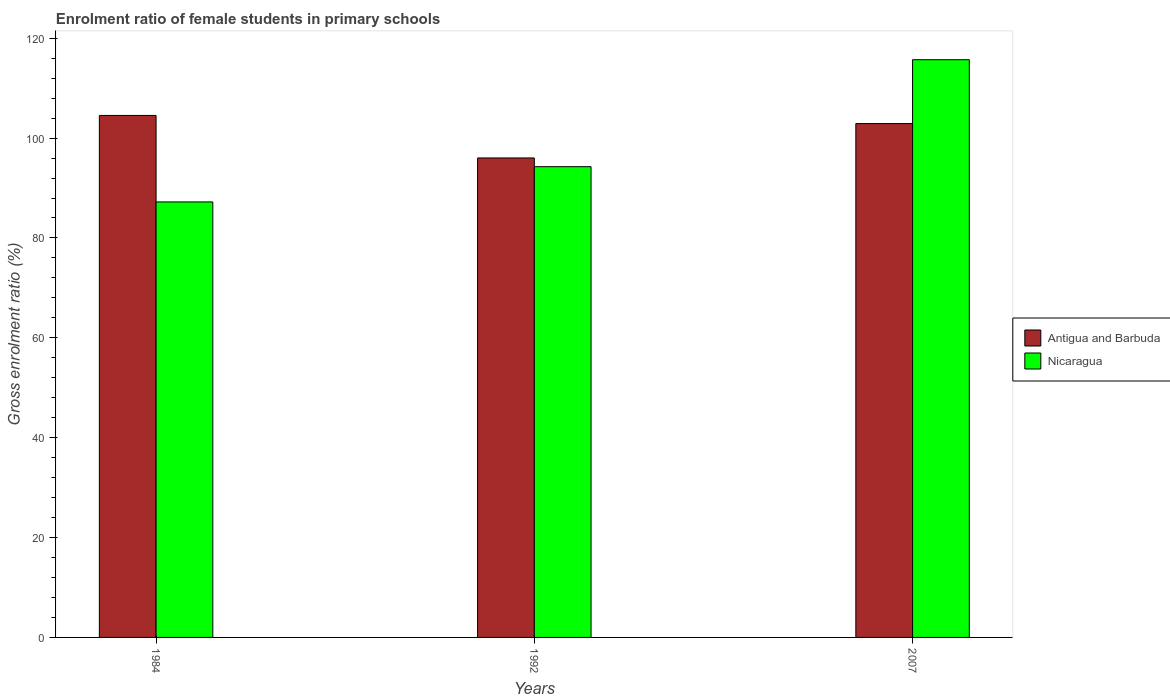How many groups of bars are there?
Provide a short and direct response. 3. Are the number of bars per tick equal to the number of legend labels?
Your response must be concise. Yes. Are the number of bars on each tick of the X-axis equal?
Provide a short and direct response. Yes. How many bars are there on the 2nd tick from the left?
Offer a terse response. 2. What is the label of the 1st group of bars from the left?
Provide a succinct answer. 1984. In how many cases, is the number of bars for a given year not equal to the number of legend labels?
Give a very brief answer. 0. What is the enrolment ratio of female students in primary schools in Antigua and Barbuda in 2007?
Provide a succinct answer. 102.91. Across all years, what is the maximum enrolment ratio of female students in primary schools in Nicaragua?
Make the answer very short. 115.7. Across all years, what is the minimum enrolment ratio of female students in primary schools in Antigua and Barbuda?
Offer a terse response. 96.03. In which year was the enrolment ratio of female students in primary schools in Nicaragua minimum?
Your answer should be very brief. 1984. What is the total enrolment ratio of female students in primary schools in Nicaragua in the graph?
Give a very brief answer. 297.19. What is the difference between the enrolment ratio of female students in primary schools in Antigua and Barbuda in 1984 and that in 1992?
Your answer should be compact. 8.51. What is the difference between the enrolment ratio of female students in primary schools in Nicaragua in 1992 and the enrolment ratio of female students in primary schools in Antigua and Barbuda in 1984?
Provide a succinct answer. -10.26. What is the average enrolment ratio of female students in primary schools in Antigua and Barbuda per year?
Keep it short and to the point. 101.16. In the year 2007, what is the difference between the enrolment ratio of female students in primary schools in Antigua and Barbuda and enrolment ratio of female students in primary schools in Nicaragua?
Ensure brevity in your answer.  -12.79. What is the ratio of the enrolment ratio of female students in primary schools in Antigua and Barbuda in 1984 to that in 2007?
Your answer should be compact. 1.02. What is the difference between the highest and the second highest enrolment ratio of female students in primary schools in Antigua and Barbuda?
Keep it short and to the point. 1.63. What is the difference between the highest and the lowest enrolment ratio of female students in primary schools in Nicaragua?
Keep it short and to the point. 28.48. What does the 1st bar from the left in 1984 represents?
Keep it short and to the point. Antigua and Barbuda. What does the 1st bar from the right in 1984 represents?
Offer a very short reply. Nicaragua. How many bars are there?
Make the answer very short. 6. Are all the bars in the graph horizontal?
Give a very brief answer. No. Does the graph contain grids?
Give a very brief answer. No. How are the legend labels stacked?
Provide a short and direct response. Vertical. What is the title of the graph?
Offer a terse response. Enrolment ratio of female students in primary schools. What is the label or title of the X-axis?
Your response must be concise. Years. What is the Gross enrolment ratio (%) in Antigua and Barbuda in 1984?
Provide a short and direct response. 104.54. What is the Gross enrolment ratio (%) of Nicaragua in 1984?
Your response must be concise. 87.22. What is the Gross enrolment ratio (%) of Antigua and Barbuda in 1992?
Make the answer very short. 96.03. What is the Gross enrolment ratio (%) of Nicaragua in 1992?
Ensure brevity in your answer.  94.28. What is the Gross enrolment ratio (%) in Antigua and Barbuda in 2007?
Offer a very short reply. 102.91. What is the Gross enrolment ratio (%) in Nicaragua in 2007?
Ensure brevity in your answer.  115.7. Across all years, what is the maximum Gross enrolment ratio (%) of Antigua and Barbuda?
Provide a short and direct response. 104.54. Across all years, what is the maximum Gross enrolment ratio (%) in Nicaragua?
Offer a very short reply. 115.7. Across all years, what is the minimum Gross enrolment ratio (%) of Antigua and Barbuda?
Your response must be concise. 96.03. Across all years, what is the minimum Gross enrolment ratio (%) in Nicaragua?
Keep it short and to the point. 87.22. What is the total Gross enrolment ratio (%) in Antigua and Barbuda in the graph?
Provide a short and direct response. 303.47. What is the total Gross enrolment ratio (%) of Nicaragua in the graph?
Make the answer very short. 297.19. What is the difference between the Gross enrolment ratio (%) of Antigua and Barbuda in 1984 and that in 1992?
Make the answer very short. 8.51. What is the difference between the Gross enrolment ratio (%) in Nicaragua in 1984 and that in 1992?
Ensure brevity in your answer.  -7.06. What is the difference between the Gross enrolment ratio (%) of Antigua and Barbuda in 1984 and that in 2007?
Offer a very short reply. 1.63. What is the difference between the Gross enrolment ratio (%) of Nicaragua in 1984 and that in 2007?
Your response must be concise. -28.48. What is the difference between the Gross enrolment ratio (%) in Antigua and Barbuda in 1992 and that in 2007?
Keep it short and to the point. -6.88. What is the difference between the Gross enrolment ratio (%) in Nicaragua in 1992 and that in 2007?
Your response must be concise. -21.42. What is the difference between the Gross enrolment ratio (%) in Antigua and Barbuda in 1984 and the Gross enrolment ratio (%) in Nicaragua in 1992?
Provide a succinct answer. 10.26. What is the difference between the Gross enrolment ratio (%) of Antigua and Barbuda in 1984 and the Gross enrolment ratio (%) of Nicaragua in 2007?
Your response must be concise. -11.16. What is the difference between the Gross enrolment ratio (%) of Antigua and Barbuda in 1992 and the Gross enrolment ratio (%) of Nicaragua in 2007?
Offer a terse response. -19.67. What is the average Gross enrolment ratio (%) in Antigua and Barbuda per year?
Your response must be concise. 101.16. What is the average Gross enrolment ratio (%) in Nicaragua per year?
Offer a very short reply. 99.06. In the year 1984, what is the difference between the Gross enrolment ratio (%) in Antigua and Barbuda and Gross enrolment ratio (%) in Nicaragua?
Keep it short and to the point. 17.32. In the year 1992, what is the difference between the Gross enrolment ratio (%) of Antigua and Barbuda and Gross enrolment ratio (%) of Nicaragua?
Provide a succinct answer. 1.75. In the year 2007, what is the difference between the Gross enrolment ratio (%) in Antigua and Barbuda and Gross enrolment ratio (%) in Nicaragua?
Ensure brevity in your answer.  -12.79. What is the ratio of the Gross enrolment ratio (%) of Antigua and Barbuda in 1984 to that in 1992?
Your response must be concise. 1.09. What is the ratio of the Gross enrolment ratio (%) in Nicaragua in 1984 to that in 1992?
Offer a terse response. 0.93. What is the ratio of the Gross enrolment ratio (%) in Antigua and Barbuda in 1984 to that in 2007?
Offer a very short reply. 1.02. What is the ratio of the Gross enrolment ratio (%) of Nicaragua in 1984 to that in 2007?
Provide a succinct answer. 0.75. What is the ratio of the Gross enrolment ratio (%) of Antigua and Barbuda in 1992 to that in 2007?
Your answer should be compact. 0.93. What is the ratio of the Gross enrolment ratio (%) of Nicaragua in 1992 to that in 2007?
Make the answer very short. 0.81. What is the difference between the highest and the second highest Gross enrolment ratio (%) of Antigua and Barbuda?
Your answer should be compact. 1.63. What is the difference between the highest and the second highest Gross enrolment ratio (%) of Nicaragua?
Provide a short and direct response. 21.42. What is the difference between the highest and the lowest Gross enrolment ratio (%) in Antigua and Barbuda?
Make the answer very short. 8.51. What is the difference between the highest and the lowest Gross enrolment ratio (%) in Nicaragua?
Keep it short and to the point. 28.48. 